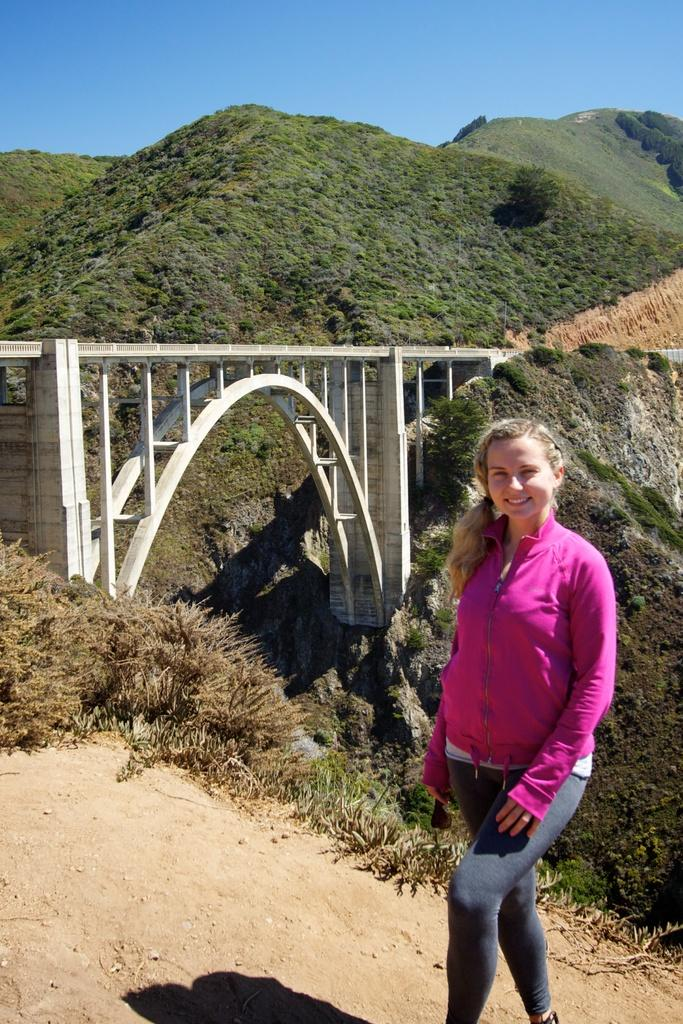What type of vegetation can be seen from left to right in the image? There is greenery visible in the image from left to right. What color is the sky in the image? The sky is blue in color. Where is the flock of beetles located in the image? There are no beetles present in the image, so a flock of beetles cannot be located. What country is depicted in the image? The image does not depict a specific country; it only shows greenery and a blue sky. 